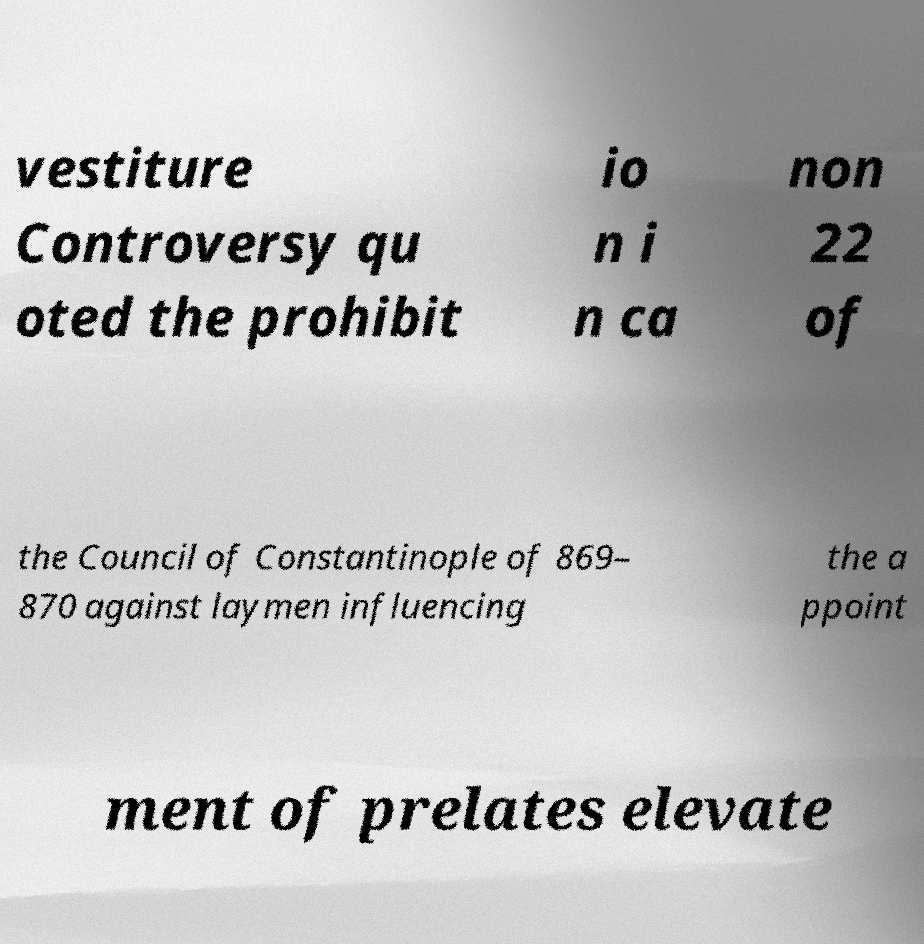For documentation purposes, I need the text within this image transcribed. Could you provide that? vestiture Controversy qu oted the prohibit io n i n ca non 22 of the Council of Constantinople of 869– 870 against laymen influencing the a ppoint ment of prelates elevate 